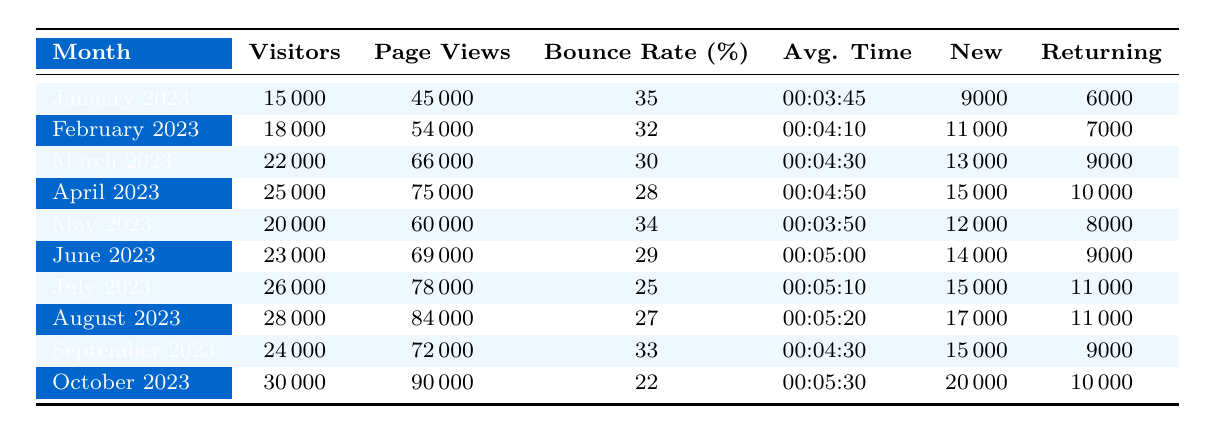What was the total number of visitors in March 2023? The total number of visitors in March 2023 can be found directly in the table, listed under the "Visitors" column corresponding to March 2023, which shows 22,000.
Answer: 22,000 What was the average bounce rate for the months recorded? To find the average bounce rate, we sum the bounce rates for each month (35 + 32 + 30 + 28 + 34 + 29 + 25 + 27 + 33 + 22 =  29.2) and divide by the number of months (10), resulting in an average bounce rate of 29.2%.
Answer: 29.2% How many new visitors were there in October 2023? The number of new visitors in October 2023 is directly listed in the table under the "New" column for that month, which shows 20,000.
Answer: 20,000 Was there a month with more returning visitors than new visitors? Yes, if we check the months in the table, April 2023 shows 10,000 returning visitors compared to 15,000 new visitors, which is not more. However, in January 2023, there were 6,000 returning visitors, which is less than new visitors, and the same applies for February and May 2023. Only for March, June, July, August, and September, returning visitors are less than new visitors. Thus, none of the months had more returning visitors than new visitors.
Answer: No What is the percentage increase in visitors from January 2023 to October 2023? First, we find the number of visitors in January 2023 (15,000) and October 2023 (30,000). The difference is 30,000 - 15,000 = 15,000. To find the percentage increase, we divide the difference by the original number (15,000) and multiply by 100: (15,000 / 15,000) * 100 = 100%.
Answer: 100% What was the month with the highest average time on site? By comparing the average time on site across the months, October 2023 has the highest average time of 00:05:30 compared to other months listed.
Answer: October 2023 What percentage of visitors in July were returning visitors? For July 2023, there were 26,000 visitors, out of which 11,000 were returning. To find the percentage, we calculate (11,000 / 26,000) * 100, which equals approximately 42.31%.
Answer: 42.31% In which month did the website have the highest page views? The month with the highest page views is October 2023, which recorded 90,000 page views as per the table.
Answer: October 2023 How many more new visitors were there in August compared to June? In August 2023, there were 17,000 new visitors, while in June 2023, there were 14,000 new visitors. The difference is 17,000 - 14,000 = 3,000.
Answer: 3,000 What was the median bounce rate over the recorded months? To find the median bounce rate, we list the bounce rates in order (22, 25, 27, 28, 29, 30, 32, 33, 34, 35). With ten data points, the median will be the average of the 5th and 6th values (29 and 30), resulting in (29 + 30) / 2 = 29.5%.
Answer: 29.5% 